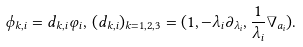Convert formula to latex. <formula><loc_0><loc_0><loc_500><loc_500>\phi _ { k , i } = d _ { k , i } \varphi _ { i } , \, ( d _ { k , i } ) _ { k = 1 , 2 , 3 } = ( 1 , - \lambda _ { i } \partial _ { \lambda _ { i } } , \frac { 1 } { \lambda _ { i } } \nabla _ { a _ { i } } ) .</formula> 